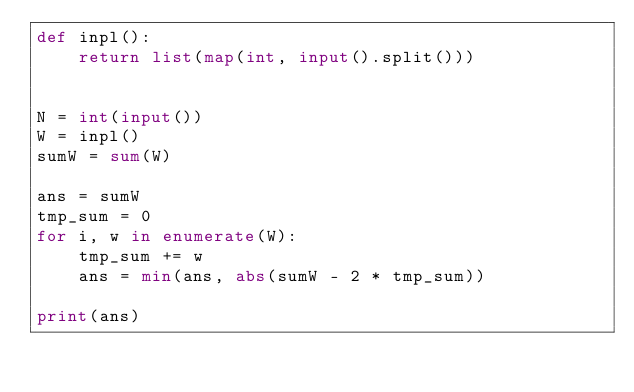<code> <loc_0><loc_0><loc_500><loc_500><_Python_>def inpl():
    return list(map(int, input().split()))


N = int(input())
W = inpl()
sumW = sum(W)

ans = sumW
tmp_sum = 0
for i, w in enumerate(W):
    tmp_sum += w
    ans = min(ans, abs(sumW - 2 * tmp_sum))

print(ans)
</code> 